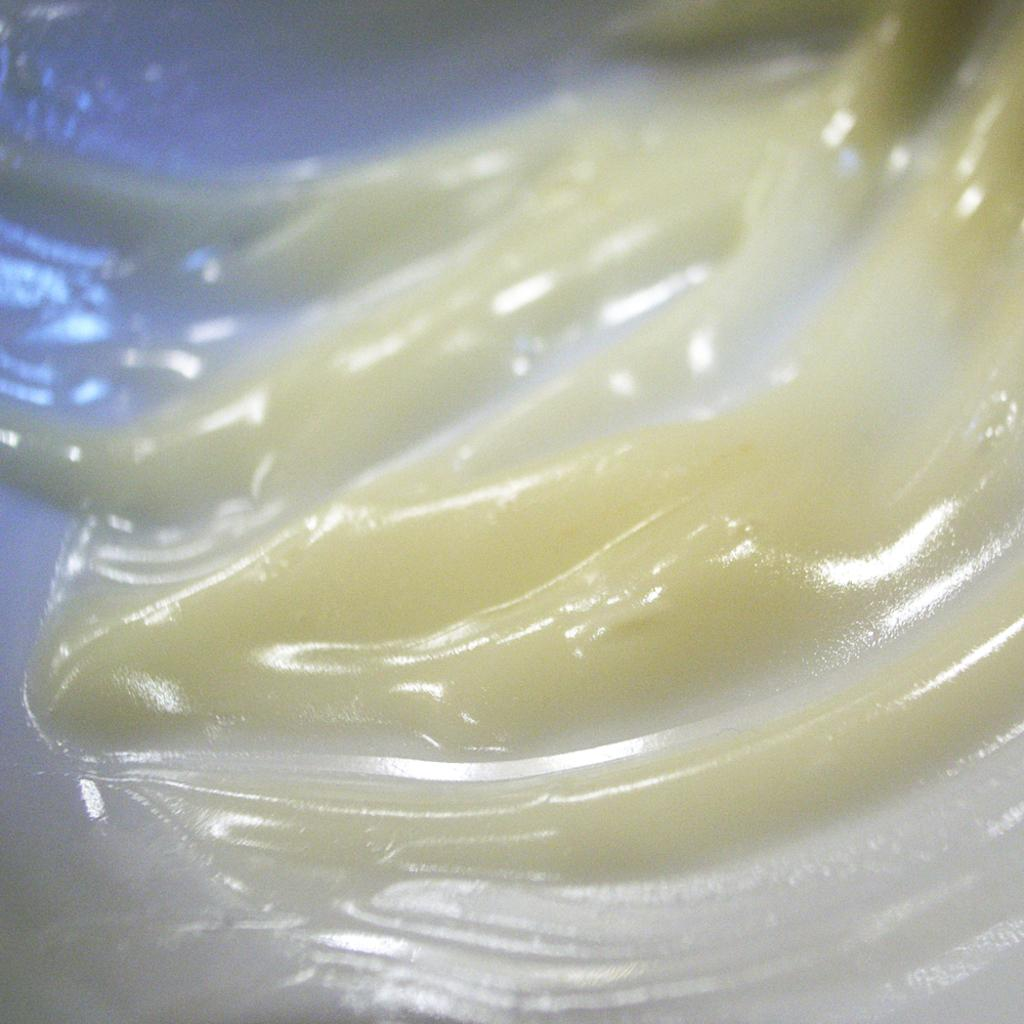What is the color of the cream in the image? The cream in the image is white. What type of chair is depicted in the image? There is no chair present in the image; it only features white cream. 